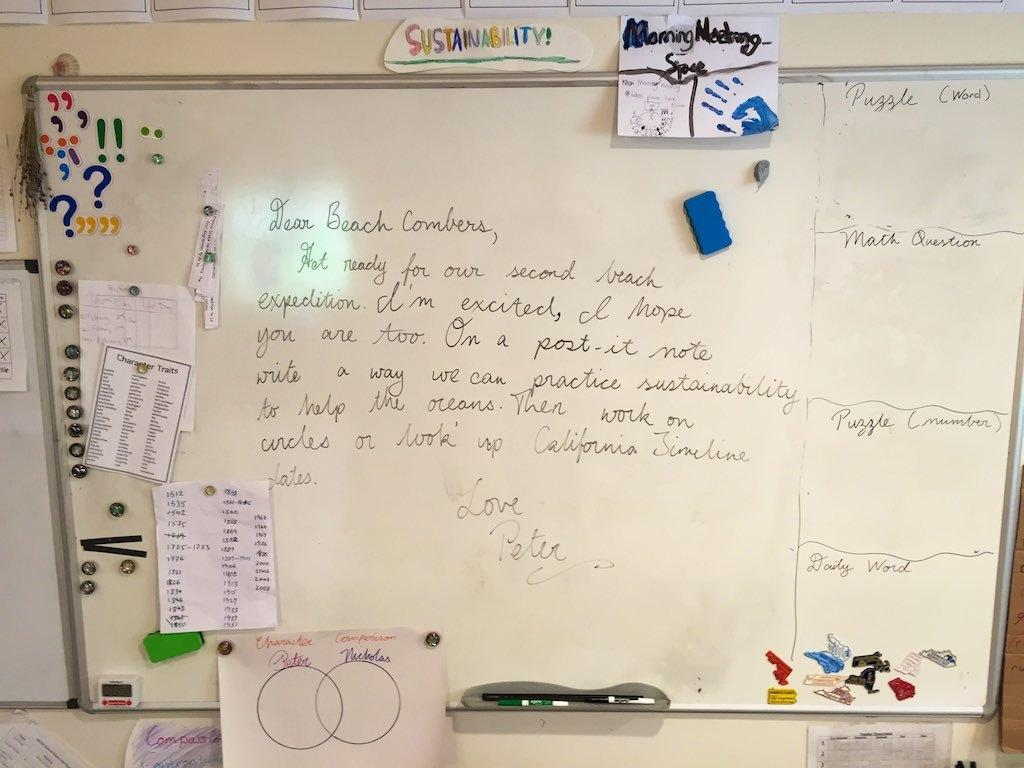<image>
Relay a brief, clear account of the picture shown. a white board has a sign reading Dear Beach Combers 